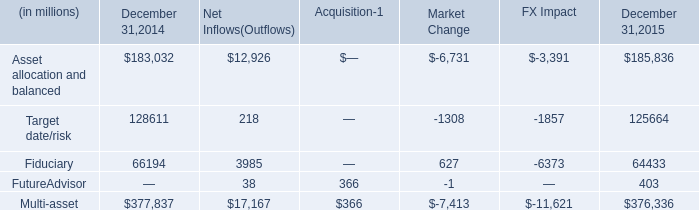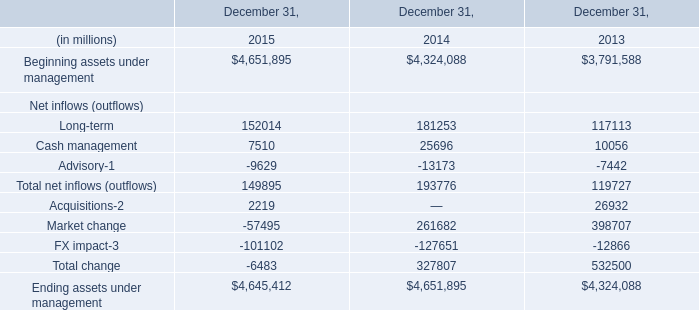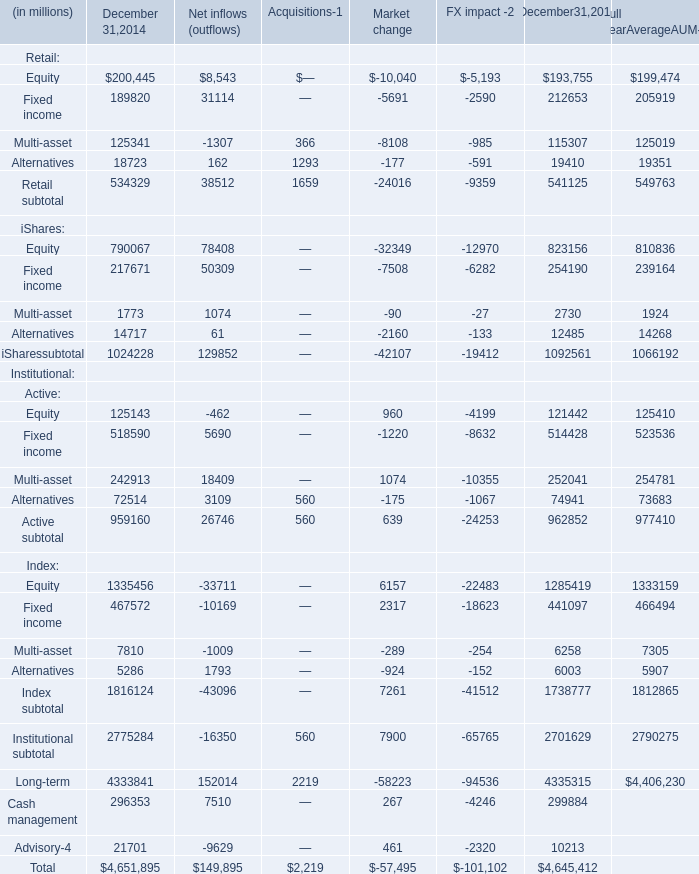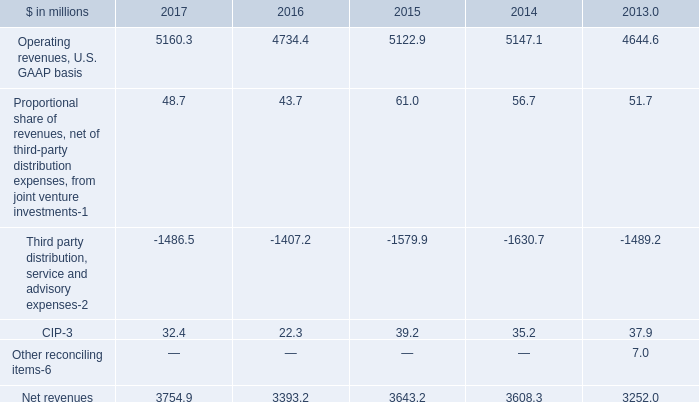What is the average value of Long-term in Table 1 and Multi-asset of December 31,2014 in Table 2 in 2014? (in million) 
Computations: ((181253 + 125341) / 2)
Answer: 153297.0. What will Beginning assets under management reach in 2016 if it continues to grow at its current rate? (in dollars in millions) 
Computations: (4651895 * (1 + ((4651895 - 4324088) / 4324088)))
Answer: 5004552.88861. 